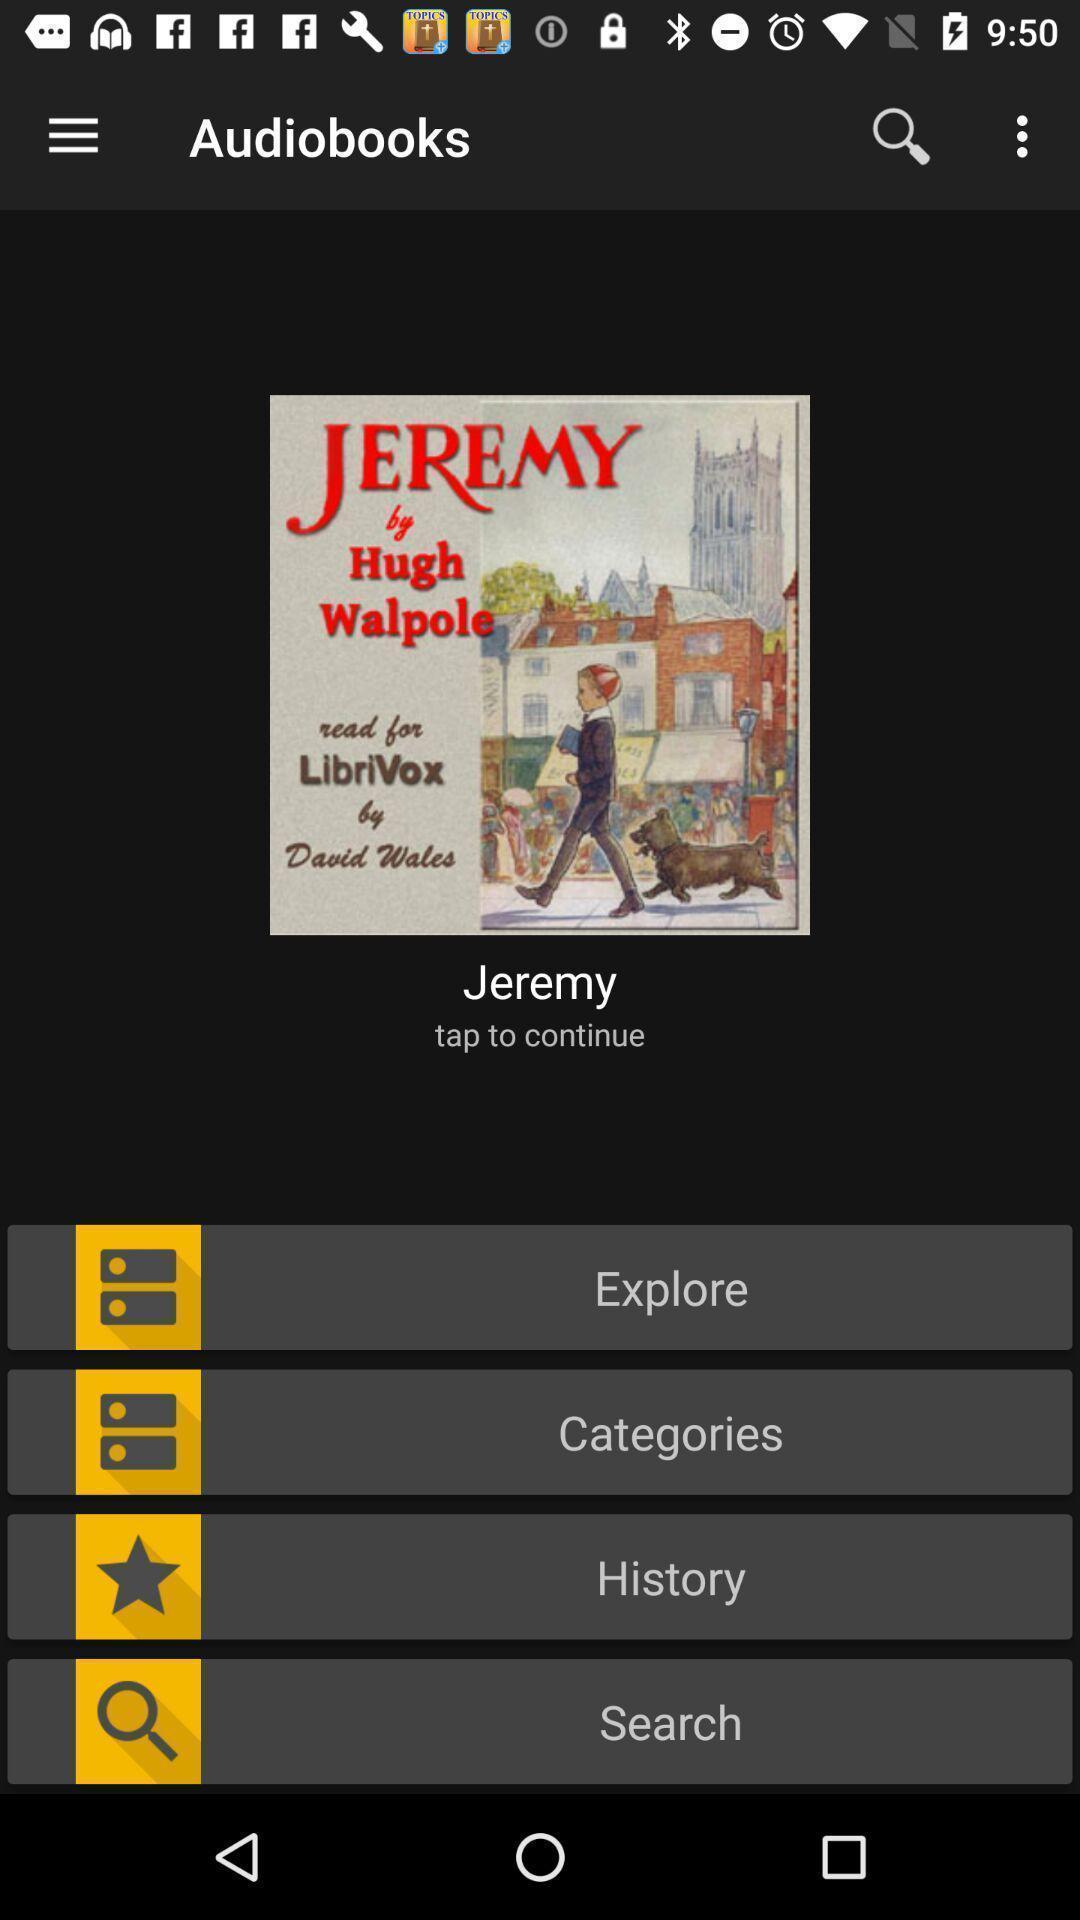Tell me about the visual elements in this screen capture. Social app for showing audio books. 